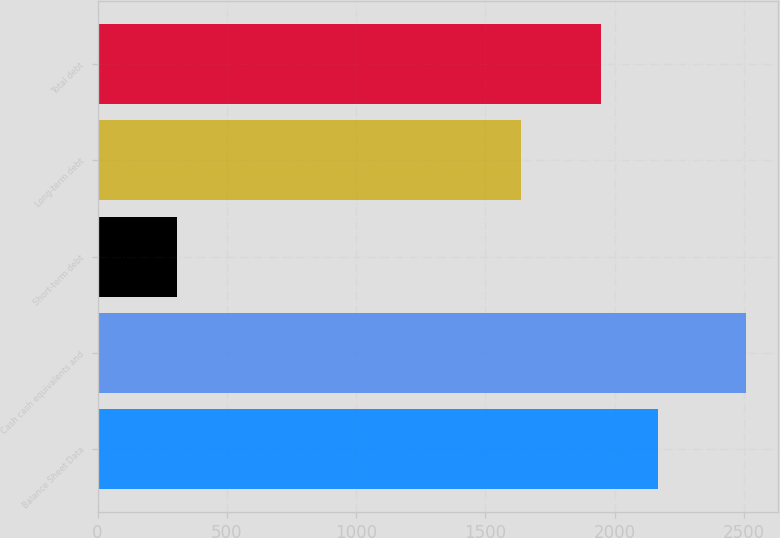Convert chart to OTSL. <chart><loc_0><loc_0><loc_500><loc_500><bar_chart><fcel>Balance Sheet Data<fcel>Cash cash equivalents and<fcel>Short-term debt<fcel>Long-term debt<fcel>Total debt<nl><fcel>2166.35<fcel>2506.1<fcel>308.6<fcel>1638<fcel>1946.6<nl></chart> 